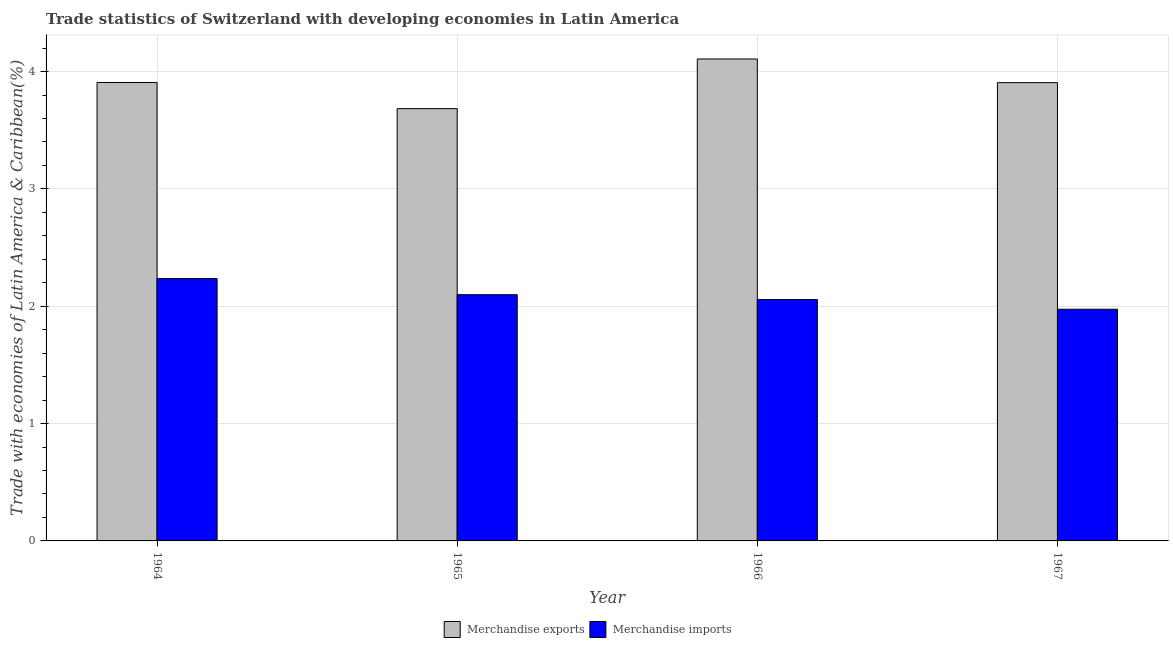How many different coloured bars are there?
Your answer should be compact. 2. What is the label of the 2nd group of bars from the left?
Your answer should be compact. 1965. What is the merchandise exports in 1964?
Provide a succinct answer. 3.91. Across all years, what is the maximum merchandise imports?
Make the answer very short. 2.24. Across all years, what is the minimum merchandise imports?
Your answer should be compact. 1.97. In which year was the merchandise exports maximum?
Offer a terse response. 1966. In which year was the merchandise exports minimum?
Provide a short and direct response. 1965. What is the total merchandise exports in the graph?
Make the answer very short. 15.6. What is the difference between the merchandise imports in 1964 and that in 1965?
Make the answer very short. 0.14. What is the difference between the merchandise imports in 1965 and the merchandise exports in 1964?
Your response must be concise. -0.14. What is the average merchandise exports per year?
Ensure brevity in your answer.  3.9. In the year 1966, what is the difference between the merchandise imports and merchandise exports?
Your answer should be compact. 0. What is the ratio of the merchandise imports in 1964 to that in 1967?
Make the answer very short. 1.13. Is the difference between the merchandise exports in 1965 and 1967 greater than the difference between the merchandise imports in 1965 and 1967?
Make the answer very short. No. What is the difference between the highest and the second highest merchandise exports?
Keep it short and to the point. 0.2. What is the difference between the highest and the lowest merchandise exports?
Offer a very short reply. 0.42. Is the sum of the merchandise exports in 1964 and 1965 greater than the maximum merchandise imports across all years?
Keep it short and to the point. Yes. What does the 2nd bar from the left in 1964 represents?
Offer a very short reply. Merchandise imports. What does the 1st bar from the right in 1965 represents?
Keep it short and to the point. Merchandise imports. How many bars are there?
Your response must be concise. 8. Does the graph contain any zero values?
Offer a very short reply. No. Does the graph contain grids?
Your response must be concise. Yes. What is the title of the graph?
Keep it short and to the point. Trade statistics of Switzerland with developing economies in Latin America. Does "Overweight" appear as one of the legend labels in the graph?
Make the answer very short. No. What is the label or title of the X-axis?
Your answer should be very brief. Year. What is the label or title of the Y-axis?
Keep it short and to the point. Trade with economies of Latin America & Caribbean(%). What is the Trade with economies of Latin America & Caribbean(%) in Merchandise exports in 1964?
Provide a short and direct response. 3.91. What is the Trade with economies of Latin America & Caribbean(%) in Merchandise imports in 1964?
Make the answer very short. 2.24. What is the Trade with economies of Latin America & Caribbean(%) of Merchandise exports in 1965?
Offer a very short reply. 3.68. What is the Trade with economies of Latin America & Caribbean(%) in Merchandise imports in 1965?
Provide a short and direct response. 2.1. What is the Trade with economies of Latin America & Caribbean(%) in Merchandise exports in 1966?
Ensure brevity in your answer.  4.11. What is the Trade with economies of Latin America & Caribbean(%) of Merchandise imports in 1966?
Offer a very short reply. 2.06. What is the Trade with economies of Latin America & Caribbean(%) in Merchandise exports in 1967?
Keep it short and to the point. 3.91. What is the Trade with economies of Latin America & Caribbean(%) in Merchandise imports in 1967?
Your answer should be very brief. 1.97. Across all years, what is the maximum Trade with economies of Latin America & Caribbean(%) in Merchandise exports?
Give a very brief answer. 4.11. Across all years, what is the maximum Trade with economies of Latin America & Caribbean(%) in Merchandise imports?
Ensure brevity in your answer.  2.24. Across all years, what is the minimum Trade with economies of Latin America & Caribbean(%) of Merchandise exports?
Make the answer very short. 3.68. Across all years, what is the minimum Trade with economies of Latin America & Caribbean(%) of Merchandise imports?
Give a very brief answer. 1.97. What is the total Trade with economies of Latin America & Caribbean(%) in Merchandise exports in the graph?
Your answer should be very brief. 15.6. What is the total Trade with economies of Latin America & Caribbean(%) in Merchandise imports in the graph?
Give a very brief answer. 8.37. What is the difference between the Trade with economies of Latin America & Caribbean(%) of Merchandise exports in 1964 and that in 1965?
Keep it short and to the point. 0.22. What is the difference between the Trade with economies of Latin America & Caribbean(%) in Merchandise imports in 1964 and that in 1965?
Provide a short and direct response. 0.14. What is the difference between the Trade with economies of Latin America & Caribbean(%) of Merchandise exports in 1964 and that in 1966?
Keep it short and to the point. -0.2. What is the difference between the Trade with economies of Latin America & Caribbean(%) of Merchandise imports in 1964 and that in 1966?
Give a very brief answer. 0.18. What is the difference between the Trade with economies of Latin America & Caribbean(%) in Merchandise exports in 1964 and that in 1967?
Make the answer very short. 0. What is the difference between the Trade with economies of Latin America & Caribbean(%) in Merchandise imports in 1964 and that in 1967?
Offer a terse response. 0.26. What is the difference between the Trade with economies of Latin America & Caribbean(%) of Merchandise exports in 1965 and that in 1966?
Keep it short and to the point. -0.42. What is the difference between the Trade with economies of Latin America & Caribbean(%) of Merchandise imports in 1965 and that in 1966?
Your answer should be very brief. 0.04. What is the difference between the Trade with economies of Latin America & Caribbean(%) of Merchandise exports in 1965 and that in 1967?
Provide a succinct answer. -0.22. What is the difference between the Trade with economies of Latin America & Caribbean(%) of Merchandise imports in 1965 and that in 1967?
Your response must be concise. 0.12. What is the difference between the Trade with economies of Latin America & Caribbean(%) in Merchandise exports in 1966 and that in 1967?
Ensure brevity in your answer.  0.2. What is the difference between the Trade with economies of Latin America & Caribbean(%) in Merchandise imports in 1966 and that in 1967?
Your answer should be very brief. 0.08. What is the difference between the Trade with economies of Latin America & Caribbean(%) in Merchandise exports in 1964 and the Trade with economies of Latin America & Caribbean(%) in Merchandise imports in 1965?
Offer a terse response. 1.81. What is the difference between the Trade with economies of Latin America & Caribbean(%) in Merchandise exports in 1964 and the Trade with economies of Latin America & Caribbean(%) in Merchandise imports in 1966?
Ensure brevity in your answer.  1.85. What is the difference between the Trade with economies of Latin America & Caribbean(%) in Merchandise exports in 1964 and the Trade with economies of Latin America & Caribbean(%) in Merchandise imports in 1967?
Keep it short and to the point. 1.93. What is the difference between the Trade with economies of Latin America & Caribbean(%) of Merchandise exports in 1965 and the Trade with economies of Latin America & Caribbean(%) of Merchandise imports in 1966?
Your answer should be very brief. 1.63. What is the difference between the Trade with economies of Latin America & Caribbean(%) of Merchandise exports in 1965 and the Trade with economies of Latin America & Caribbean(%) of Merchandise imports in 1967?
Ensure brevity in your answer.  1.71. What is the difference between the Trade with economies of Latin America & Caribbean(%) in Merchandise exports in 1966 and the Trade with economies of Latin America & Caribbean(%) in Merchandise imports in 1967?
Provide a short and direct response. 2.13. What is the average Trade with economies of Latin America & Caribbean(%) of Merchandise exports per year?
Offer a terse response. 3.9. What is the average Trade with economies of Latin America & Caribbean(%) in Merchandise imports per year?
Your answer should be very brief. 2.09. In the year 1964, what is the difference between the Trade with economies of Latin America & Caribbean(%) in Merchandise exports and Trade with economies of Latin America & Caribbean(%) in Merchandise imports?
Your response must be concise. 1.67. In the year 1965, what is the difference between the Trade with economies of Latin America & Caribbean(%) of Merchandise exports and Trade with economies of Latin America & Caribbean(%) of Merchandise imports?
Offer a very short reply. 1.59. In the year 1966, what is the difference between the Trade with economies of Latin America & Caribbean(%) of Merchandise exports and Trade with economies of Latin America & Caribbean(%) of Merchandise imports?
Ensure brevity in your answer.  2.05. In the year 1967, what is the difference between the Trade with economies of Latin America & Caribbean(%) of Merchandise exports and Trade with economies of Latin America & Caribbean(%) of Merchandise imports?
Provide a succinct answer. 1.93. What is the ratio of the Trade with economies of Latin America & Caribbean(%) in Merchandise exports in 1964 to that in 1965?
Provide a succinct answer. 1.06. What is the ratio of the Trade with economies of Latin America & Caribbean(%) in Merchandise imports in 1964 to that in 1965?
Keep it short and to the point. 1.07. What is the ratio of the Trade with economies of Latin America & Caribbean(%) in Merchandise exports in 1964 to that in 1966?
Ensure brevity in your answer.  0.95. What is the ratio of the Trade with economies of Latin America & Caribbean(%) in Merchandise imports in 1964 to that in 1966?
Provide a succinct answer. 1.09. What is the ratio of the Trade with economies of Latin America & Caribbean(%) in Merchandise exports in 1964 to that in 1967?
Provide a short and direct response. 1. What is the ratio of the Trade with economies of Latin America & Caribbean(%) in Merchandise imports in 1964 to that in 1967?
Offer a very short reply. 1.13. What is the ratio of the Trade with economies of Latin America & Caribbean(%) in Merchandise exports in 1965 to that in 1966?
Offer a very short reply. 0.9. What is the ratio of the Trade with economies of Latin America & Caribbean(%) in Merchandise imports in 1965 to that in 1966?
Your response must be concise. 1.02. What is the ratio of the Trade with economies of Latin America & Caribbean(%) of Merchandise exports in 1965 to that in 1967?
Offer a very short reply. 0.94. What is the ratio of the Trade with economies of Latin America & Caribbean(%) of Merchandise imports in 1965 to that in 1967?
Provide a succinct answer. 1.06. What is the ratio of the Trade with economies of Latin America & Caribbean(%) in Merchandise exports in 1966 to that in 1967?
Your answer should be compact. 1.05. What is the ratio of the Trade with economies of Latin America & Caribbean(%) of Merchandise imports in 1966 to that in 1967?
Your answer should be compact. 1.04. What is the difference between the highest and the second highest Trade with economies of Latin America & Caribbean(%) in Merchandise exports?
Your response must be concise. 0.2. What is the difference between the highest and the second highest Trade with economies of Latin America & Caribbean(%) in Merchandise imports?
Keep it short and to the point. 0.14. What is the difference between the highest and the lowest Trade with economies of Latin America & Caribbean(%) of Merchandise exports?
Provide a succinct answer. 0.42. What is the difference between the highest and the lowest Trade with economies of Latin America & Caribbean(%) of Merchandise imports?
Give a very brief answer. 0.26. 